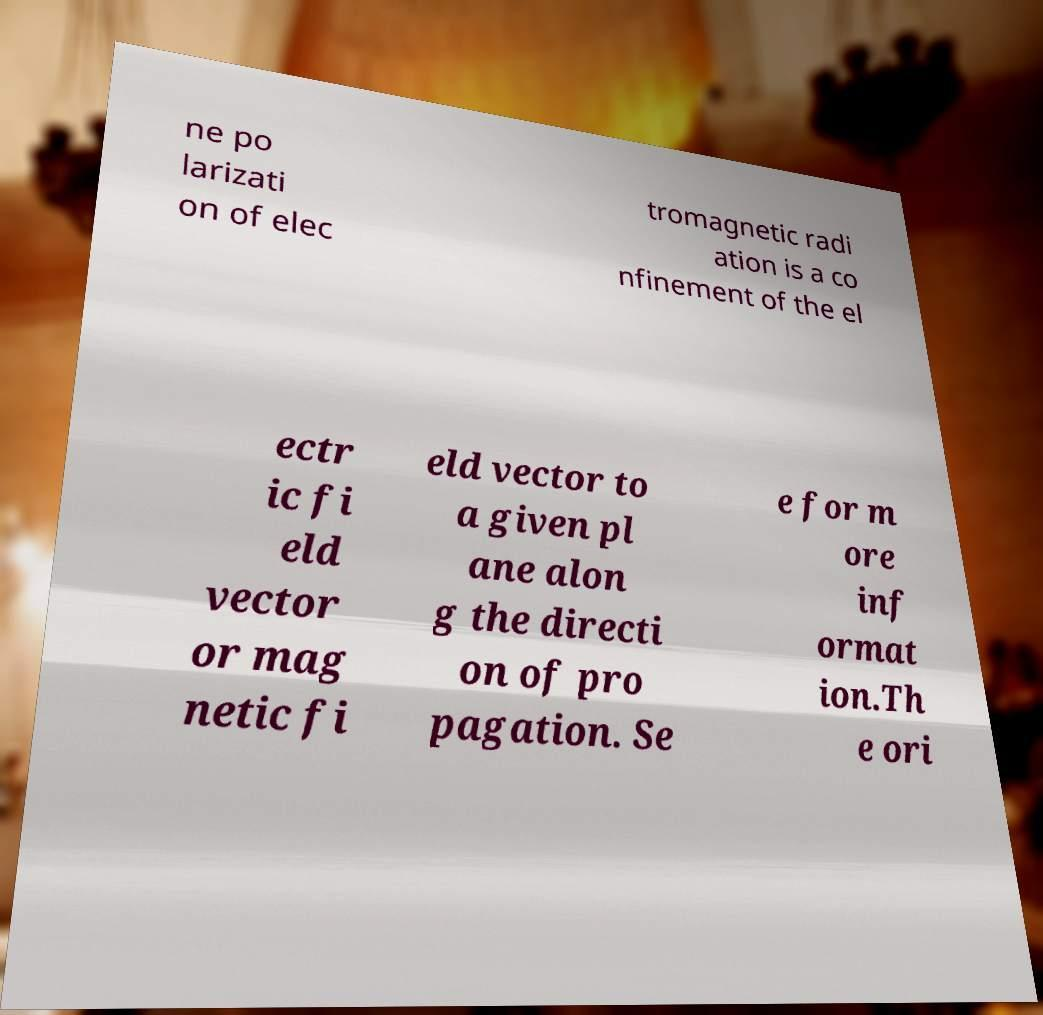Can you read and provide the text displayed in the image?This photo seems to have some interesting text. Can you extract and type it out for me? ne po larizati on of elec tromagnetic radi ation is a co nfinement of the el ectr ic fi eld vector or mag netic fi eld vector to a given pl ane alon g the directi on of pro pagation. Se e for m ore inf ormat ion.Th e ori 